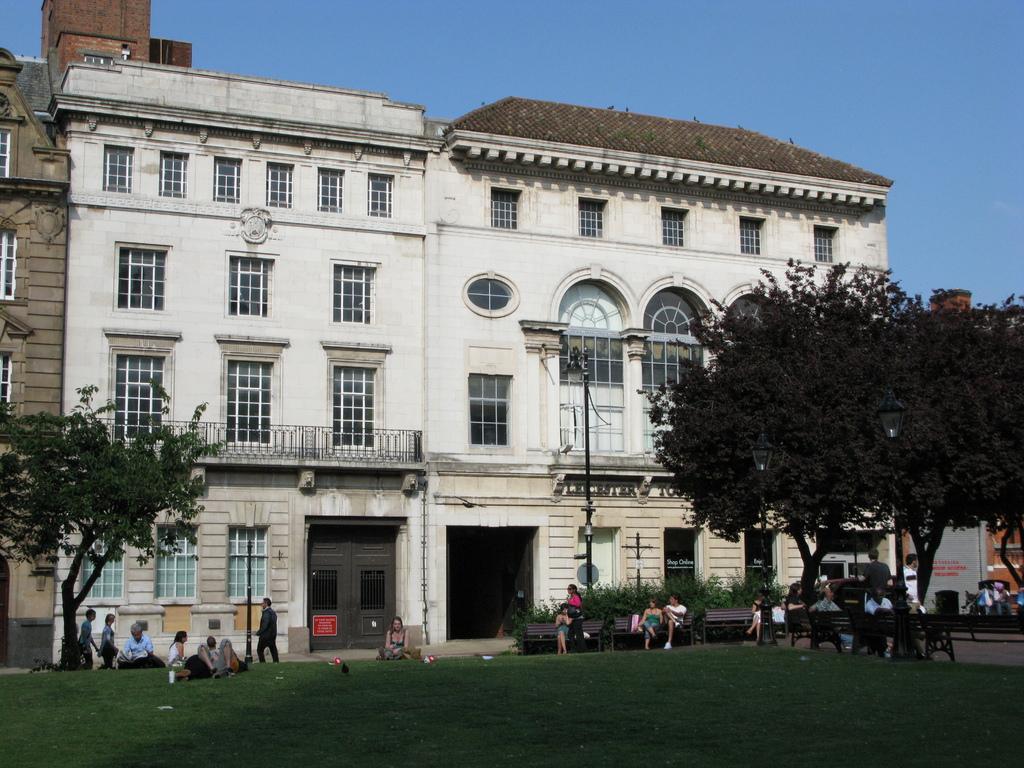Can you describe this image briefly? There are some persons and this is grass. Here we can see trees, poles, boards, benches, plants, doors, windows, and buildings. In the background there is sky. 